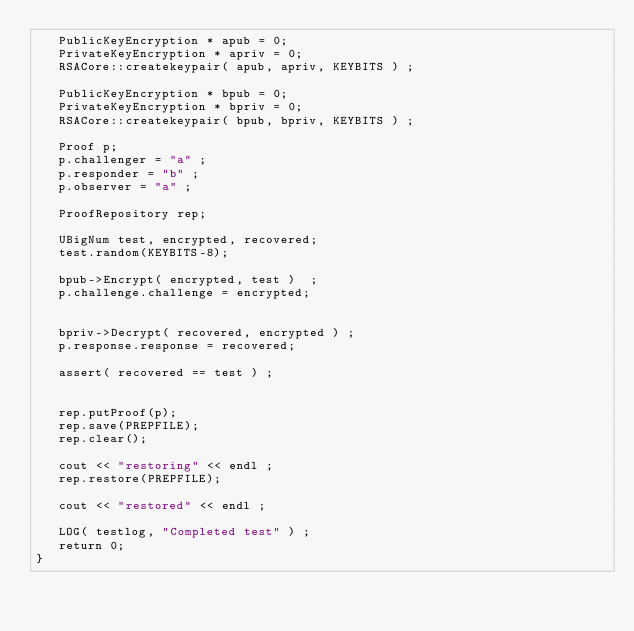Convert code to text. <code><loc_0><loc_0><loc_500><loc_500><_C++_>   PublicKeyEncryption * apub = 0; 
   PrivateKeyEncryption * apriv = 0; 
   RSACore::createkeypair( apub, apriv, KEYBITS ) ; 

   PublicKeyEncryption * bpub = 0; 
   PrivateKeyEncryption * bpriv = 0; 
   RSACore::createkeypair( bpub, bpriv, KEYBITS ) ; 

   Proof p;
   p.challenger = "a" ; 
   p.responder = "b" ; 
   p.observer = "a" ; 

   ProofRepository rep; 

   UBigNum test, encrypted, recovered;
   test.random(KEYBITS-8);

   bpub->Encrypt( encrypted, test )  ;
   p.challenge.challenge = encrypted; 


   bpriv->Decrypt( recovered, encrypted ) ;
   p.response.response = recovered; 

   assert( recovered == test ) ; 


   rep.putProof(p); 
   rep.save(PREPFILE); 
   rep.clear(); 

   cout << "restoring" << endl ; 
   rep.restore(PREPFILE); 

   cout << "restored" << endl ; 

   LOG( testlog, "Completed test" ) ; 
   return 0; 
}
</code> 